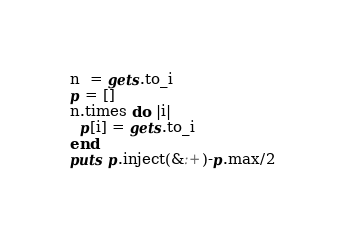<code> <loc_0><loc_0><loc_500><loc_500><_Ruby_>n  = gets.to_i
p = []
n.times do |i|
  p[i] = gets.to_i
end
puts p.inject(&:+)-p.max/2</code> 